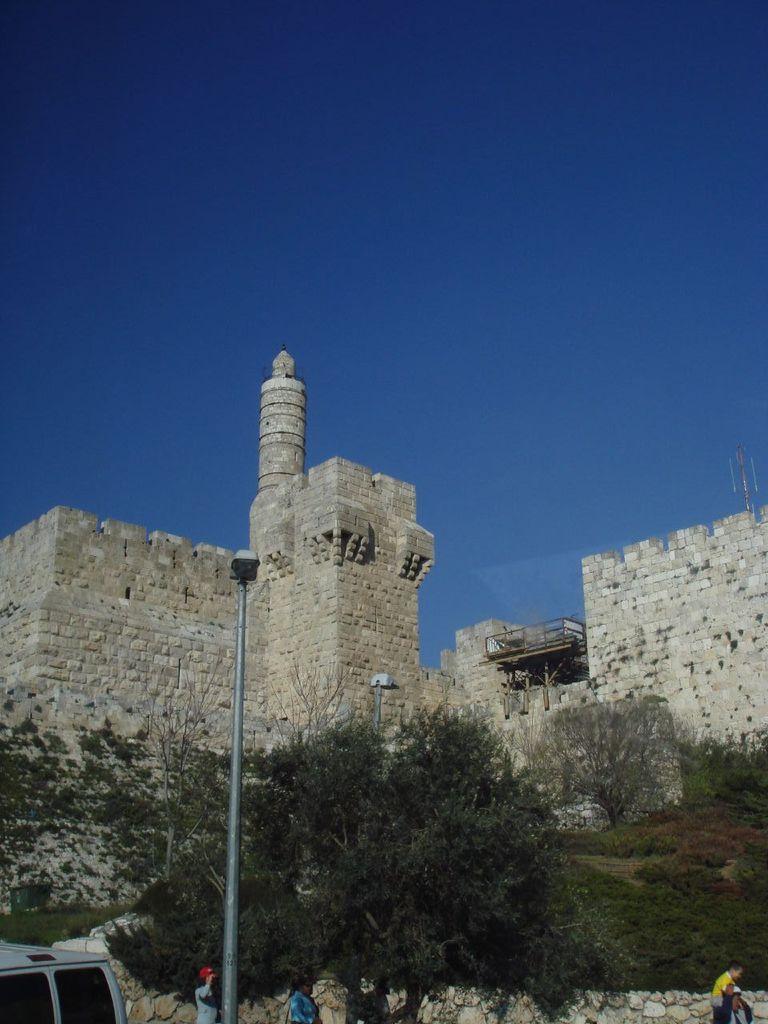Can you describe this image briefly? In this image there is a pole and people standing, in the background there are trees, fort and the sky. 